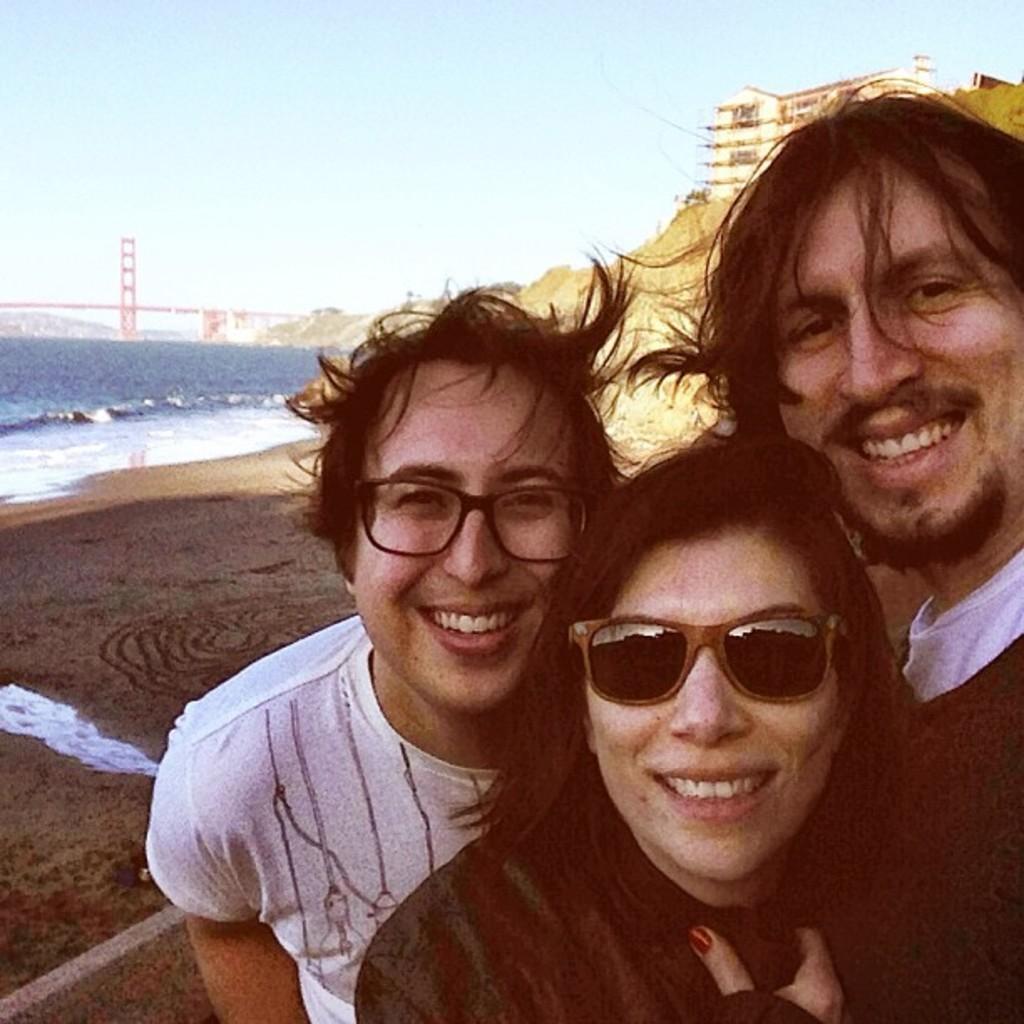In one or two sentences, can you explain what this image depicts? In the center of the image we can see three people standing and smiling. On the left there is water and we can see bridge. In the background there is a building, hill and sky. 